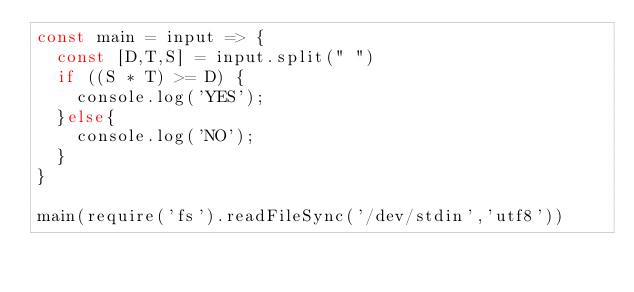<code> <loc_0><loc_0><loc_500><loc_500><_JavaScript_>const main = input => {
  const [D,T,S] = input.split(" ")
  if ((S * T) >= D) {
    console.log('YES');
  }else{
    console.log('NO');
  }
}
 
main(require('fs').readFileSync('/dev/stdin','utf8'))</code> 